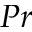<formula> <loc_0><loc_0><loc_500><loc_500>P r</formula> 